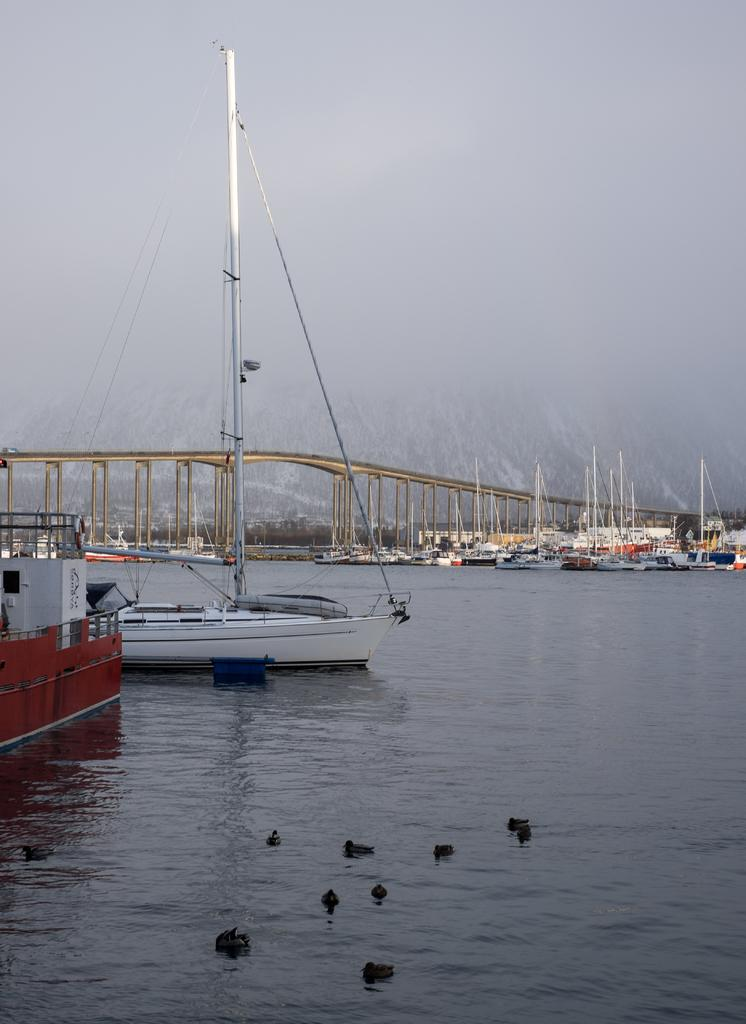What animals can be seen in the water in the foreground of the image? There are ducks in the water in the foreground of the image. What type of vehicles can be seen in the background of the image? There are boats in the background of the image. What structures can be seen in the background of the image? There is a bridge in the background of the image. What natural feature can be seen in the background of the image? There is a mountain in the background of the image. How would you describe the weather or visibility in the background of the image? The sky is foggy in the background of the image. Can you see any fish swimming near the ducks in the image? There is no mention of fish in the image, only ducks in the water. Is there a wound visible on the mountain in the background of the image? There is no mention of a wound or any damage to the mountain in the image. 